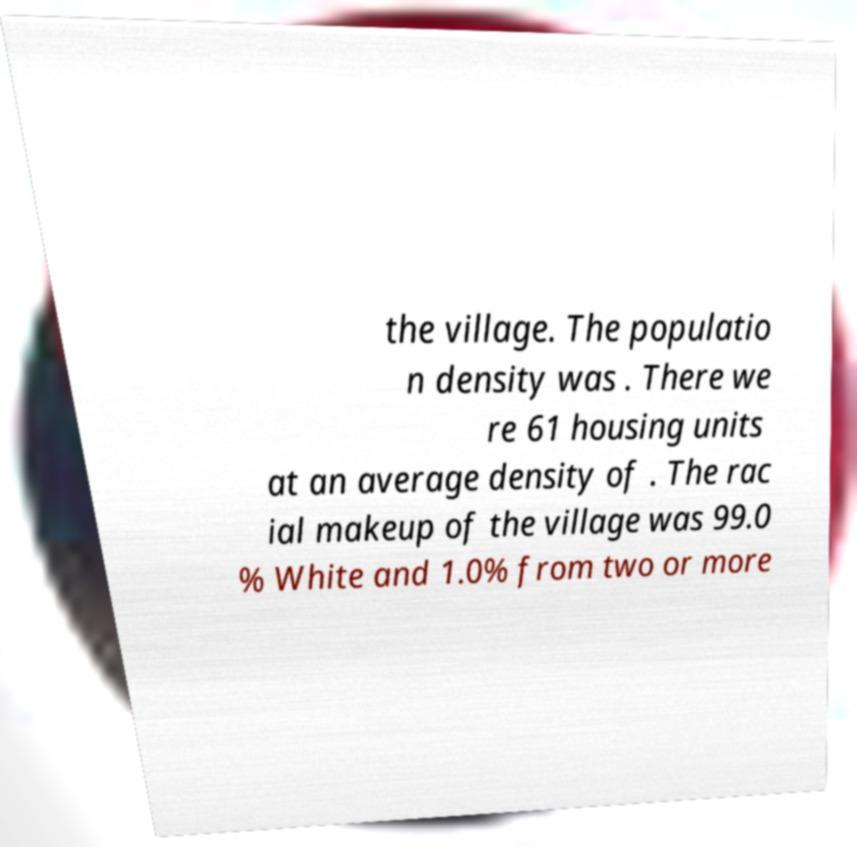Could you extract and type out the text from this image? the village. The populatio n density was . There we re 61 housing units at an average density of . The rac ial makeup of the village was 99.0 % White and 1.0% from two or more 